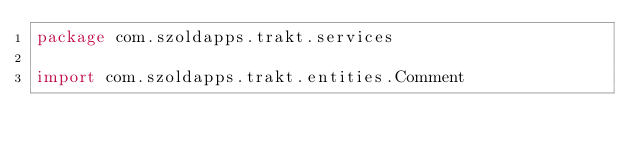<code> <loc_0><loc_0><loc_500><loc_500><_Kotlin_>package com.szoldapps.trakt.services

import com.szoldapps.trakt.entities.Comment</code> 